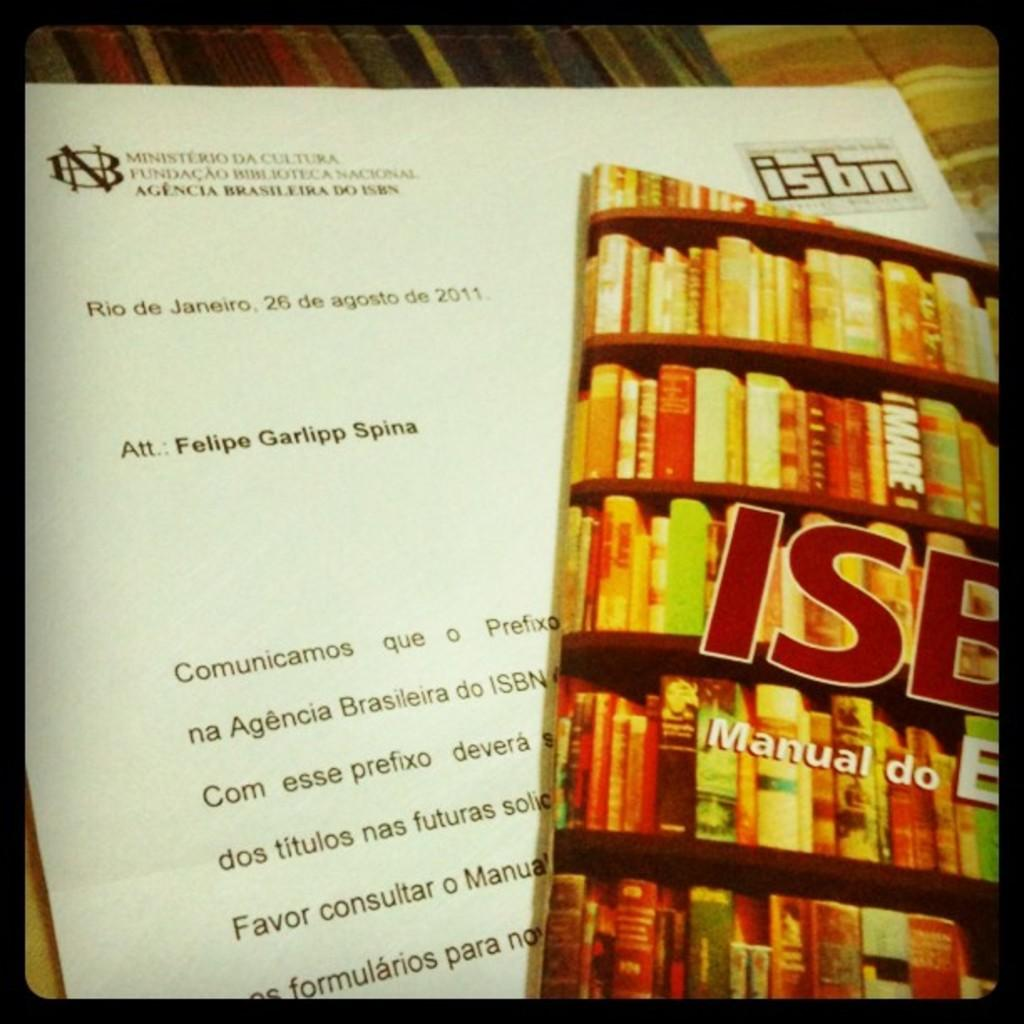<image>
Provide a brief description of the given image. A pamphlet with a letter adressed to felipe garlipp spina written in portugese. 